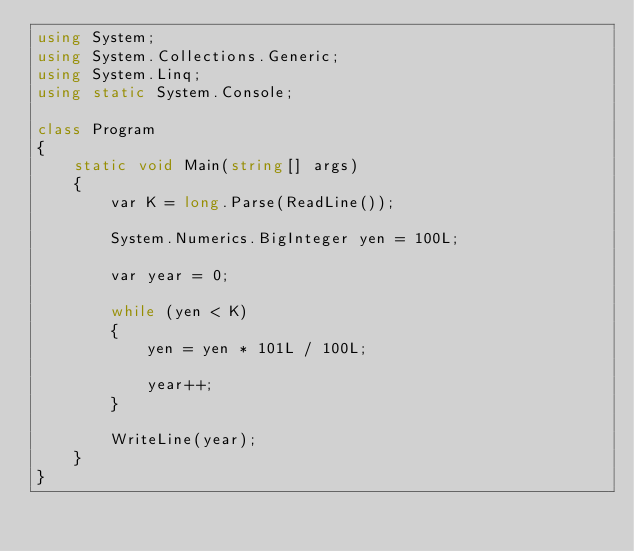Convert code to text. <code><loc_0><loc_0><loc_500><loc_500><_C#_>using System;
using System.Collections.Generic;
using System.Linq;
using static System.Console;

class Program
{
    static void Main(string[] args)
    {
        var K = long.Parse(ReadLine());

        System.Numerics.BigInteger yen = 100L;

        var year = 0;

        while (yen < K)
        {
            yen = yen * 101L / 100L;

            year++;
        }

        WriteLine(year);
    }
}
</code> 